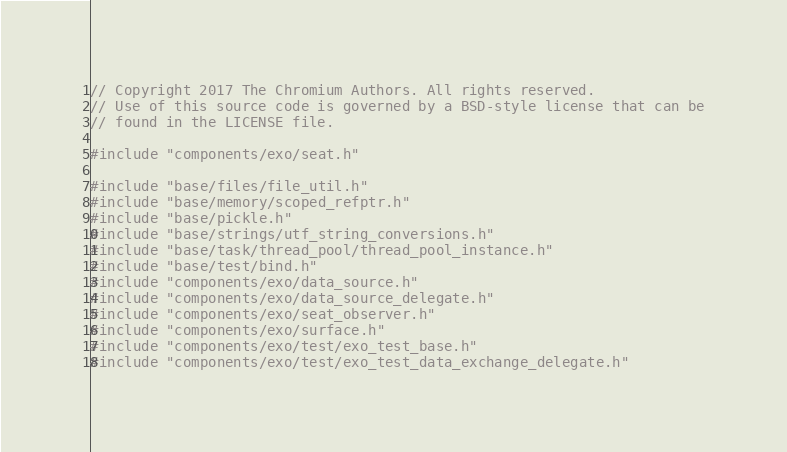Convert code to text. <code><loc_0><loc_0><loc_500><loc_500><_C++_>// Copyright 2017 The Chromium Authors. All rights reserved.
// Use of this source code is governed by a BSD-style license that can be
// found in the LICENSE file.

#include "components/exo/seat.h"

#include "base/files/file_util.h"
#include "base/memory/scoped_refptr.h"
#include "base/pickle.h"
#include "base/strings/utf_string_conversions.h"
#include "base/task/thread_pool/thread_pool_instance.h"
#include "base/test/bind.h"
#include "components/exo/data_source.h"
#include "components/exo/data_source_delegate.h"
#include "components/exo/seat_observer.h"
#include "components/exo/surface.h"
#include "components/exo/test/exo_test_base.h"
#include "components/exo/test/exo_test_data_exchange_delegate.h"</code> 